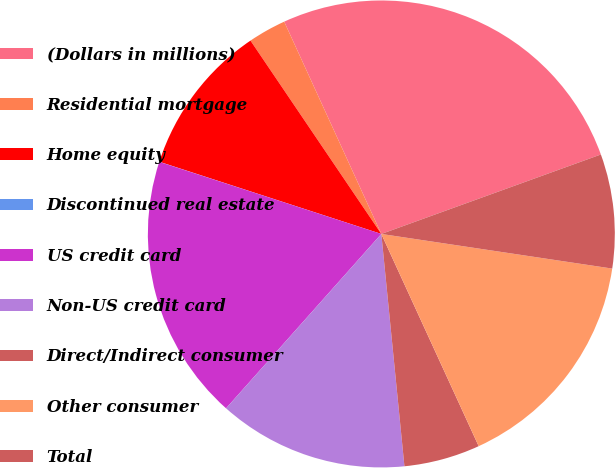Convert chart to OTSL. <chart><loc_0><loc_0><loc_500><loc_500><pie_chart><fcel>(Dollars in millions)<fcel>Residential mortgage<fcel>Home equity<fcel>Discontinued real estate<fcel>US credit card<fcel>Non-US credit card<fcel>Direct/Indirect consumer<fcel>Other consumer<fcel>Total<nl><fcel>26.31%<fcel>2.64%<fcel>10.53%<fcel>0.01%<fcel>18.42%<fcel>13.16%<fcel>5.27%<fcel>15.79%<fcel>7.9%<nl></chart> 